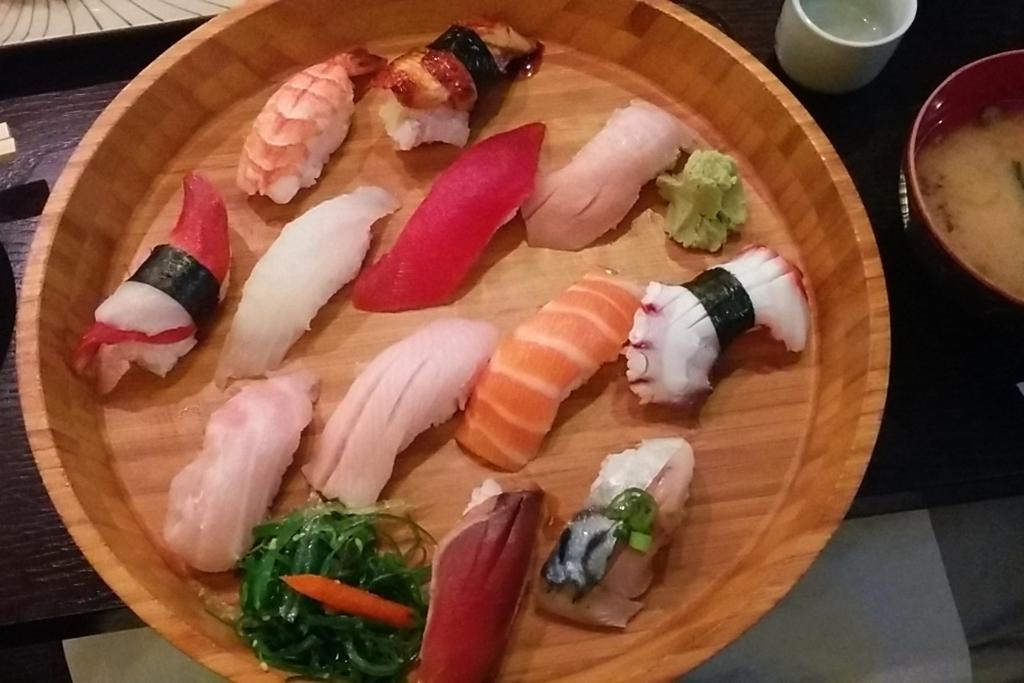Describe this image in one or two sentences. In this image, we can see some eatable things are there on the wooden bowl. On the right side, we can see bowl and cup. These items are placed on the surface. 